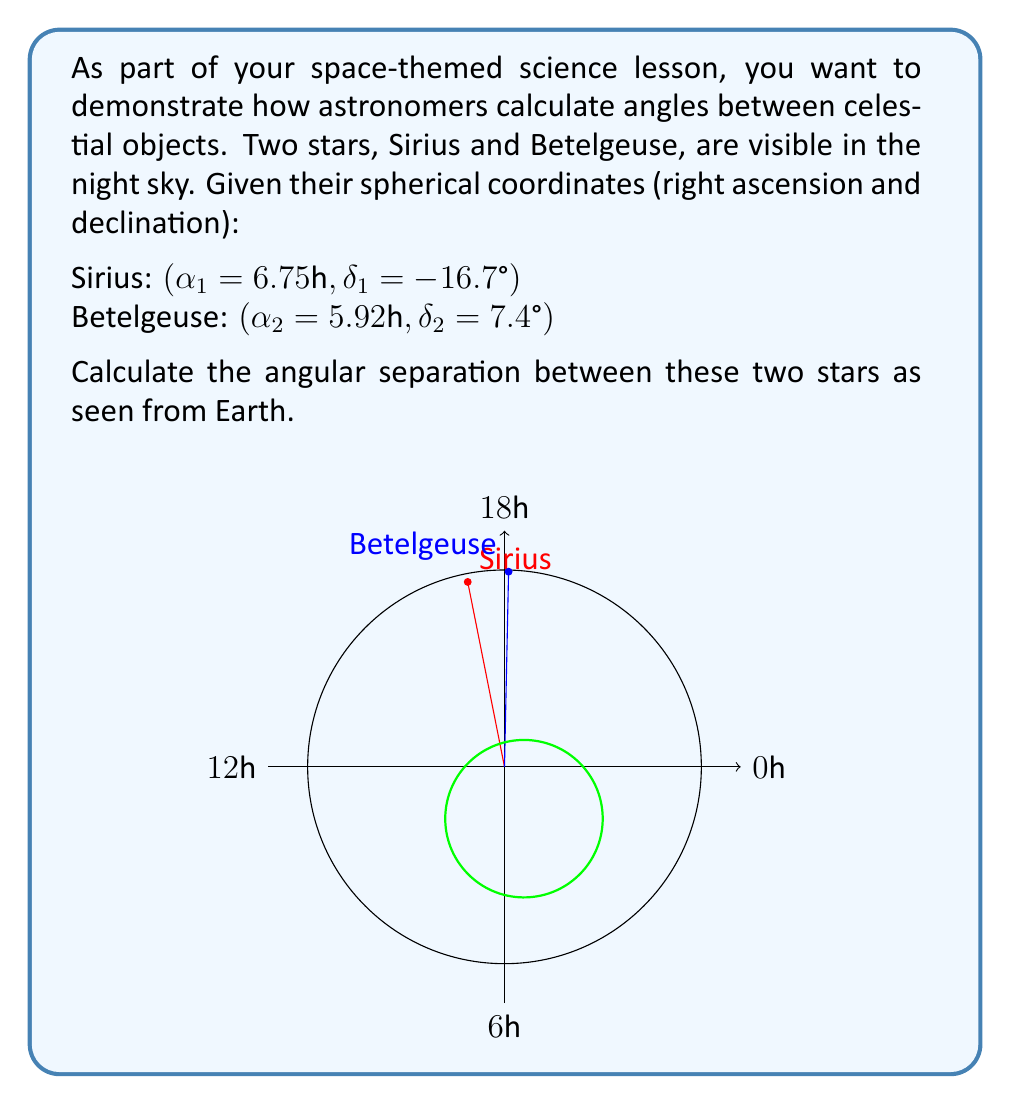Can you answer this question? To find the angular separation between two stars using their spherical coordinates, we can follow these steps:

1) First, we need to convert the right ascension (α) from hours to degrees:
   $\alpha_1 = 6.75\text{h} \times 15°/\text{h} = 101.25°$
   $\alpha_2 = 5.92\text{h} \times 15°/\text{h} = 88.8°$

2) Now we have the spherical coordinates in degrees:
   Sirius: $(\alpha_1 = 101.25°, \delta_1 = -16.7°)$
   Betelgeuse: $(\alpha_2 = 88.8°, \delta_2 = 7.4°)$

3) We can use the spherical law of cosines to calculate the angular separation (θ):

   $$\cos(\theta) = \sin(\delta_1)\sin(\delta_2) + \cos(\delta_1)\cos(\delta_2)\cos(\alpha_1 - \alpha_2)$$

4) Let's substitute our values (converting degrees to radians):

   $$\cos(\theta) = \sin(-16.7° \cdot \frac{\pi}{180})\sin(7.4° \cdot \frac{\pi}{180}) + \cos(-16.7° \cdot \frac{\pi}{180})\cos(7.4° \cdot \frac{\pi}{180})\cos((101.25° - 88.8°) \cdot \frac{\pi}{180})$$

5) Calculating this (you can use a scientific calculator):

   $$\cos(\theta) \approx 0.9781$$

6) To get θ, we take the inverse cosine (arccos) of both sides:

   $$\theta = \arccos(0.9781) \approx 0.2094 \text{ radians}$$

7) Convert radians to degrees:

   $$\theta \approx 0.2094 \cdot \frac{180°}{\pi} \approx 12.0°$$

Thus, the angular separation between Sirius and Betelgeuse is approximately 12.0°.
Answer: $12.0°$ 